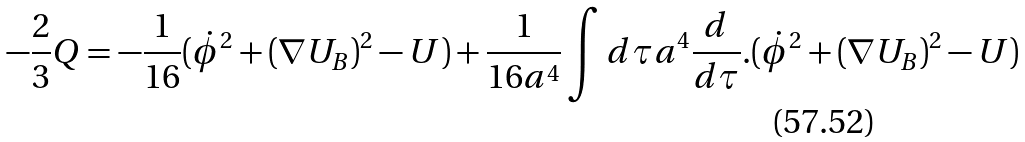Convert formula to latex. <formula><loc_0><loc_0><loc_500><loc_500>- \frac { 2 } { 3 } Q = - \frac { 1 } { 1 6 } ( \dot { \phi } ^ { 2 } + ( \nabla U _ { B } ) ^ { 2 } - U ) + \frac { 1 } { 1 6 a ^ { 4 } } \int d \tau a ^ { 4 } \frac { d } { d \tau } . ( \dot { \phi } ^ { 2 } + ( \nabla U _ { B } ) ^ { 2 } - U )</formula> 